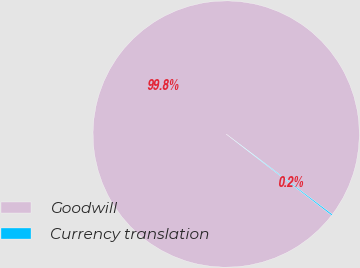Convert chart. <chart><loc_0><loc_0><loc_500><loc_500><pie_chart><fcel>Goodwill<fcel>Currency translation<nl><fcel>99.85%<fcel>0.15%<nl></chart> 